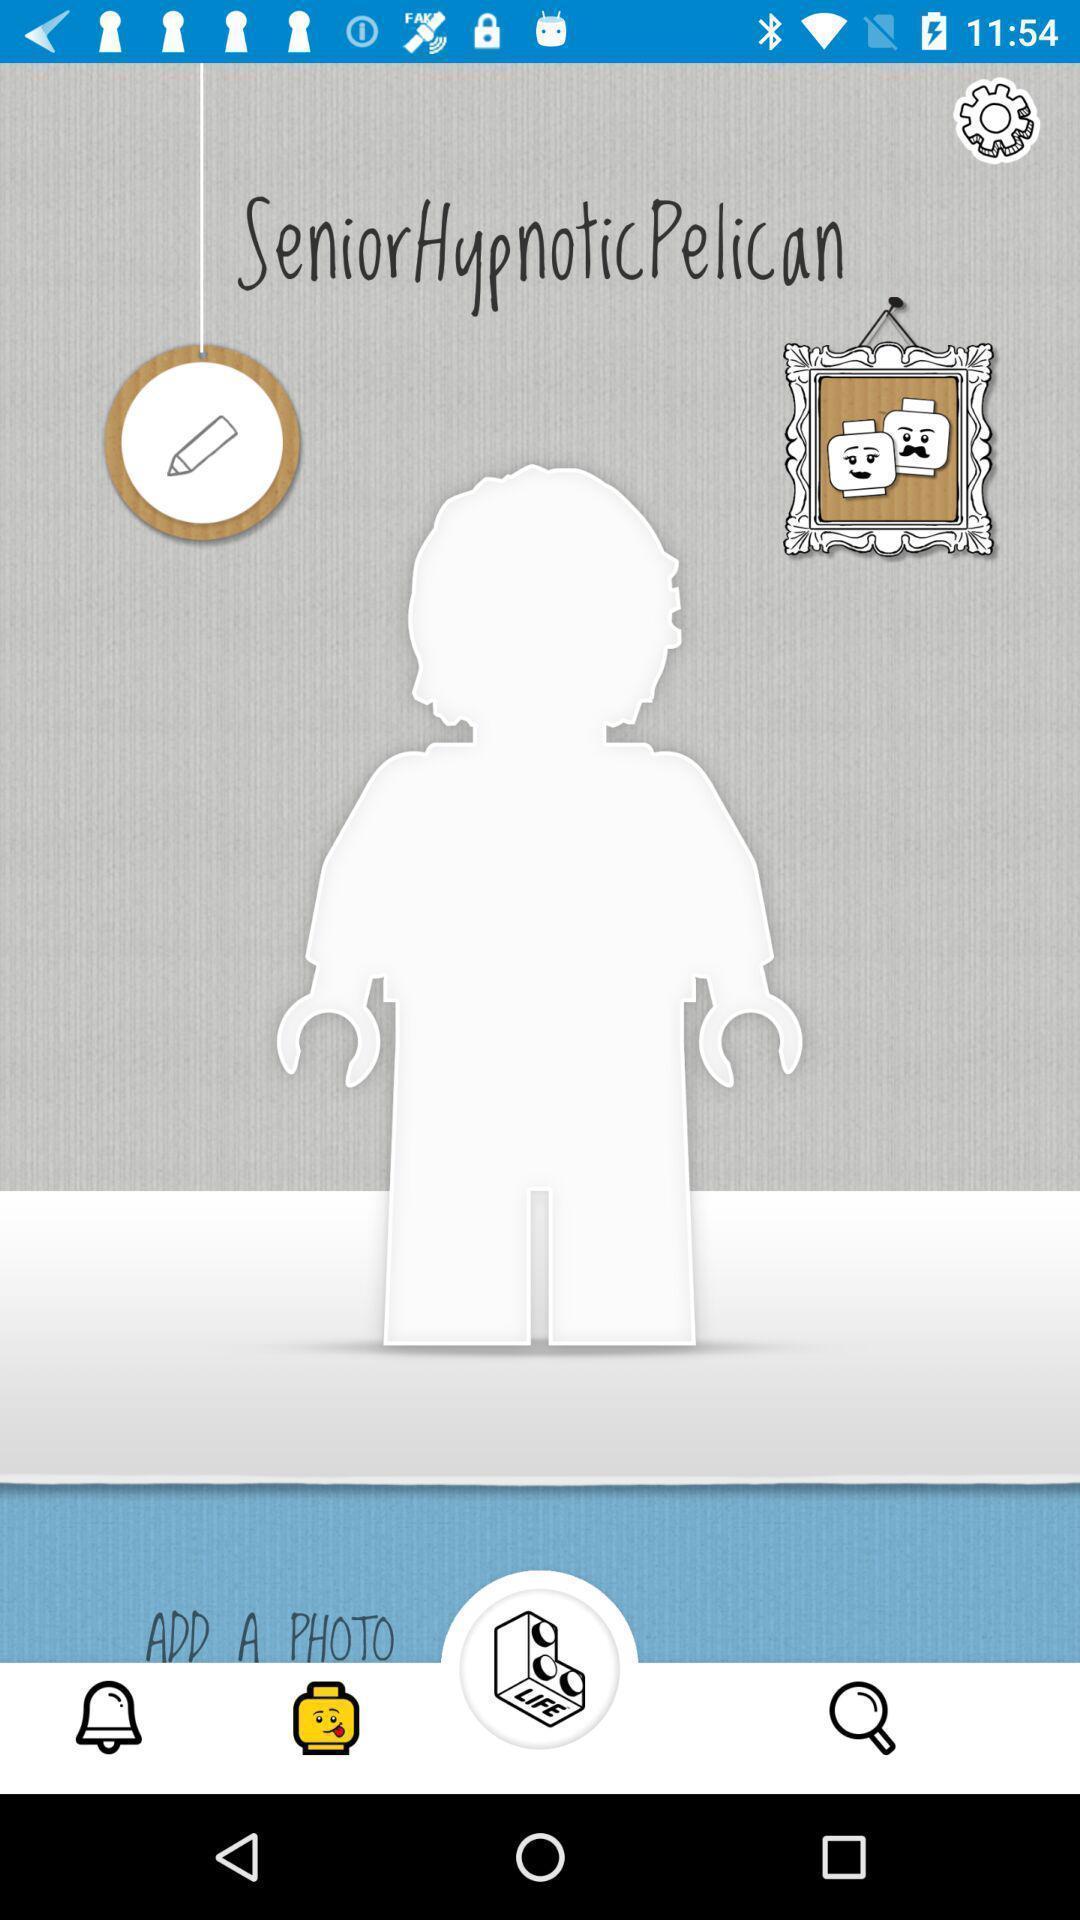Please provide a description for this image. Welcome page displaying with different options. 